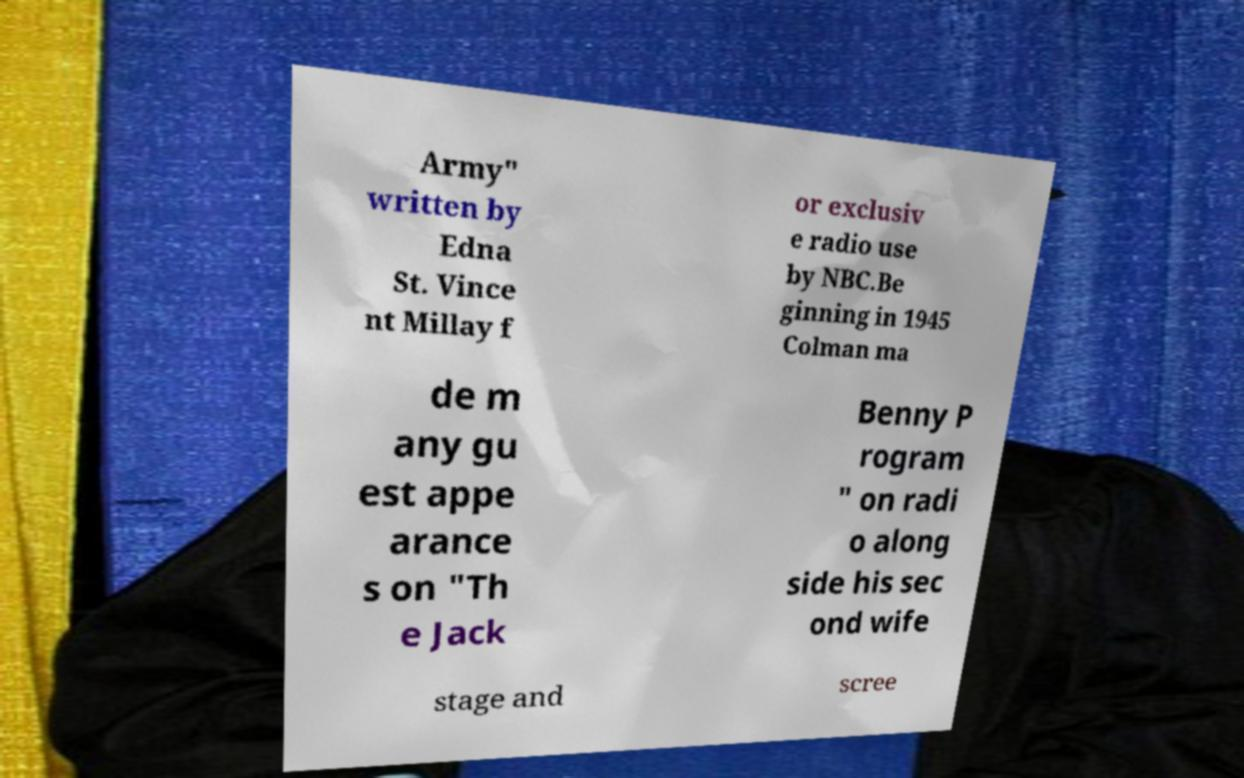There's text embedded in this image that I need extracted. Can you transcribe it verbatim? Army" written by Edna St. Vince nt Millay f or exclusiv e radio use by NBC.Be ginning in 1945 Colman ma de m any gu est appe arance s on "Th e Jack Benny P rogram " on radi o along side his sec ond wife stage and scree 